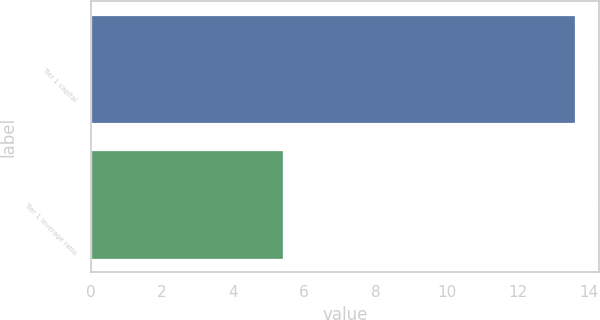Convert chart to OTSL. <chart><loc_0><loc_0><loc_500><loc_500><bar_chart><fcel>Tier 1 capital<fcel>Tier 1 leverage ratio<nl><fcel>13.6<fcel>5.4<nl></chart> 